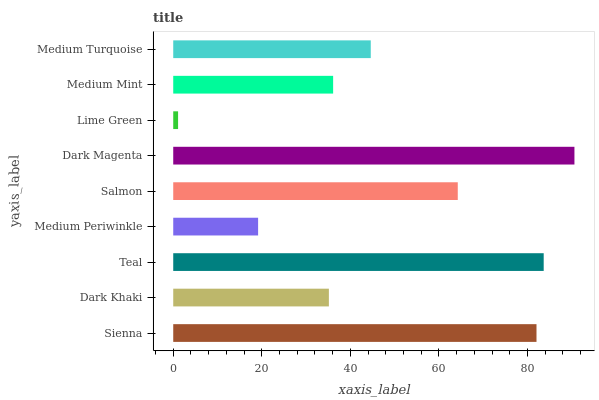Is Lime Green the minimum?
Answer yes or no. Yes. Is Dark Magenta the maximum?
Answer yes or no. Yes. Is Dark Khaki the minimum?
Answer yes or no. No. Is Dark Khaki the maximum?
Answer yes or no. No. Is Sienna greater than Dark Khaki?
Answer yes or no. Yes. Is Dark Khaki less than Sienna?
Answer yes or no. Yes. Is Dark Khaki greater than Sienna?
Answer yes or no. No. Is Sienna less than Dark Khaki?
Answer yes or no. No. Is Medium Turquoise the high median?
Answer yes or no. Yes. Is Medium Turquoise the low median?
Answer yes or no. Yes. Is Lime Green the high median?
Answer yes or no. No. Is Teal the low median?
Answer yes or no. No. 